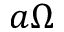<formula> <loc_0><loc_0><loc_500><loc_500>a \Omega</formula> 